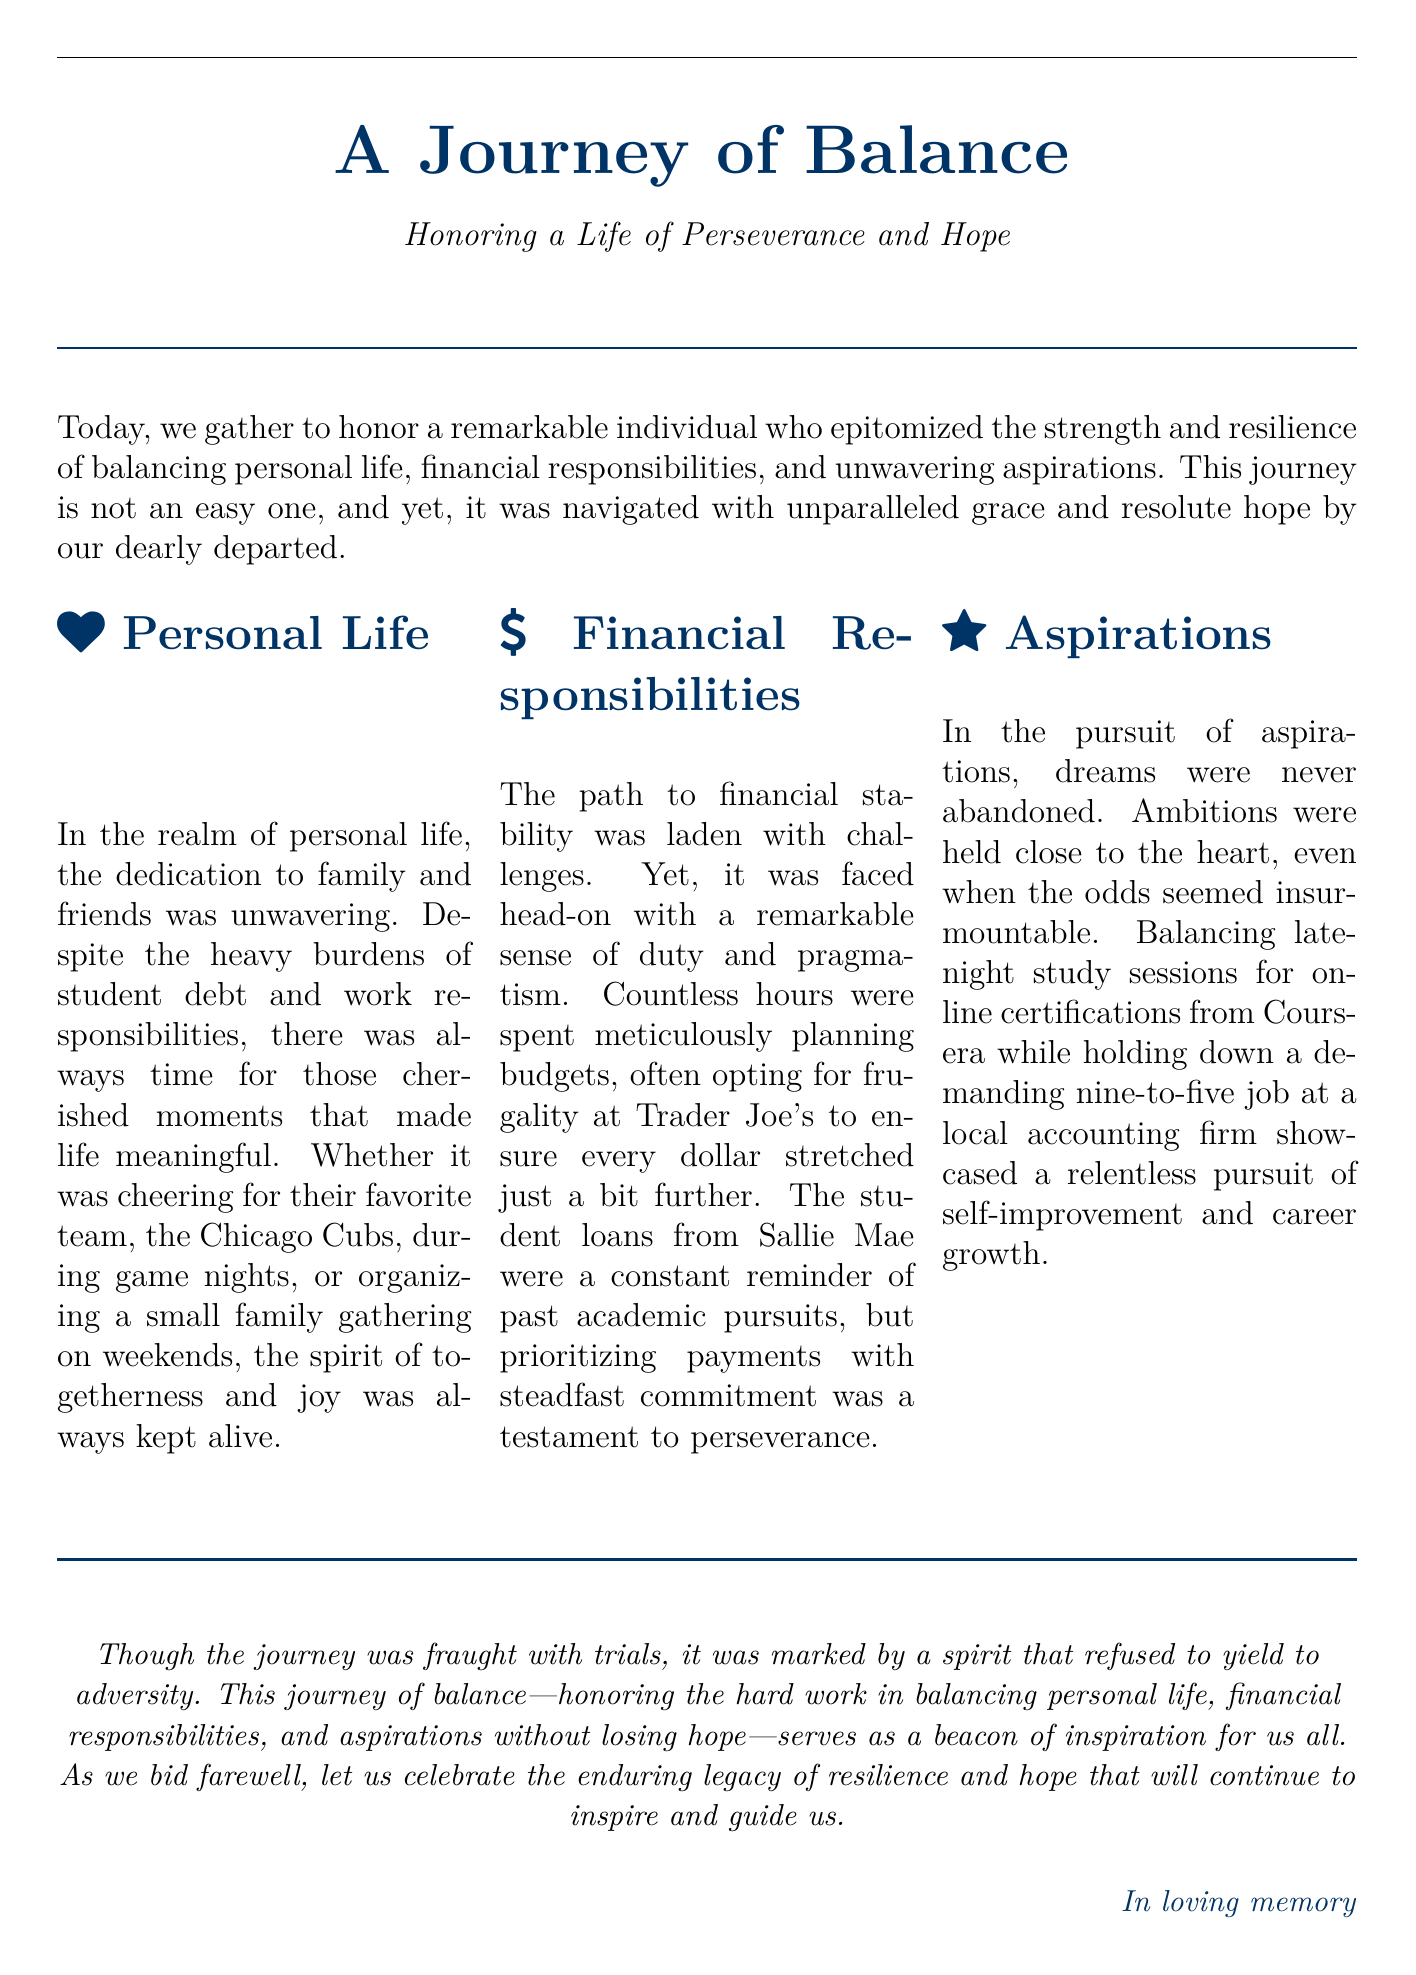What is the title of the eulogy? The title of the eulogy is explicitly stated at the beginning of the document.
Answer: A Journey of Balance What color is used for the section headers? The document specifies the color used for section headers to enhance visual appeal.
Answer: Deep blue Which sports team did the individual support? The document includes a specific detail about a favorite sports team that reflects personal interests.
Answer: Chicago Cubs What platform was used for online certifications? The eulogy mentions a particular online learning platform that highlights the individual's commitment to self-improvement.
Answer: Coursera How did the individual approach financial responsibilities? The approach to financial responsibilities is described, reflecting their method of handling challenges.
Answer: Frugality What was the work role of the individual mentioned? The document states the professional position held by the individual in the workforce.
Answer: Accounting firm What was a constant reminder of past academic pursuits? The text provides insight into financial challenges tied to education, emphasizing the burden carried.
Answer: Student loans What does the eulogy inspire others to remember? The closing sentiment of the document outlines the legacy the individual left behind.
Answer: Resilience and hope 